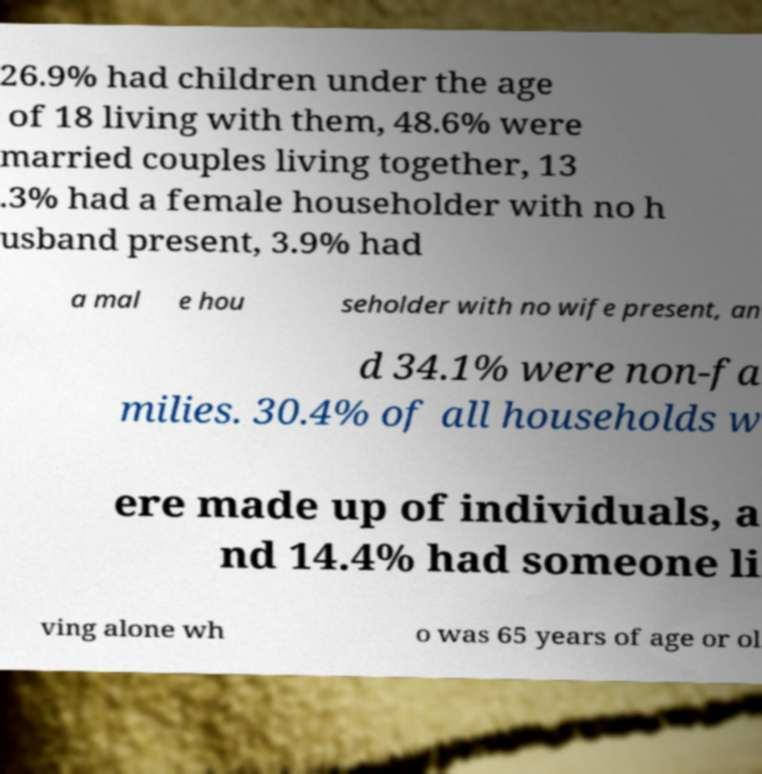What messages or text are displayed in this image? I need them in a readable, typed format. 26.9% had children under the age of 18 living with them, 48.6% were married couples living together, 13 .3% had a female householder with no h usband present, 3.9% had a mal e hou seholder with no wife present, an d 34.1% were non-fa milies. 30.4% of all households w ere made up of individuals, a nd 14.4% had someone li ving alone wh o was 65 years of age or ol 